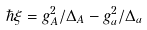<formula> <loc_0><loc_0><loc_500><loc_500>\hbar { \xi } = g _ { A } ^ { 2 } / \Delta _ { A } - g _ { a } ^ { 2 } / \Delta _ { a }</formula> 